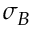Convert formula to latex. <formula><loc_0><loc_0><loc_500><loc_500>\sigma _ { B }</formula> 